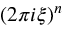Convert formula to latex. <formula><loc_0><loc_0><loc_500><loc_500>( 2 \pi i \xi ) ^ { n }</formula> 